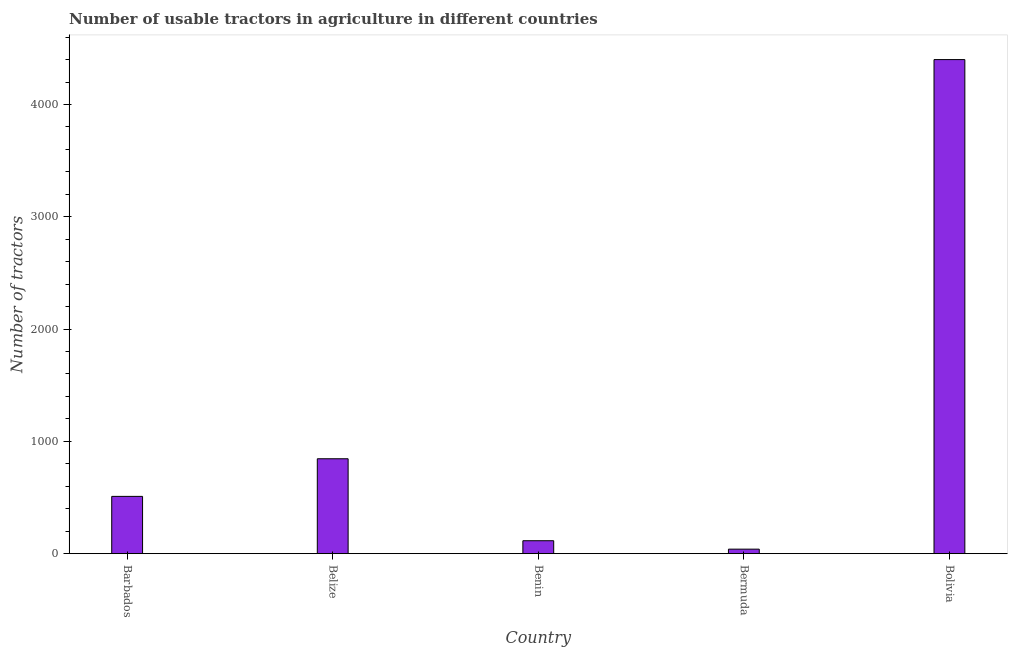Does the graph contain any zero values?
Give a very brief answer. No. What is the title of the graph?
Provide a succinct answer. Number of usable tractors in agriculture in different countries. What is the label or title of the X-axis?
Your answer should be very brief. Country. What is the label or title of the Y-axis?
Make the answer very short. Number of tractors. What is the number of tractors in Belize?
Keep it short and to the point. 845. Across all countries, what is the maximum number of tractors?
Offer a terse response. 4400. In which country was the number of tractors minimum?
Offer a terse response. Bermuda. What is the sum of the number of tractors?
Provide a succinct answer. 5910. What is the difference between the number of tractors in Barbados and Bermuda?
Provide a short and direct response. 470. What is the average number of tractors per country?
Make the answer very short. 1182. What is the median number of tractors?
Keep it short and to the point. 510. What is the ratio of the number of tractors in Bermuda to that in Bolivia?
Provide a short and direct response. 0.01. What is the difference between the highest and the second highest number of tractors?
Your answer should be compact. 3555. Is the sum of the number of tractors in Barbados and Benin greater than the maximum number of tractors across all countries?
Offer a terse response. No. What is the difference between the highest and the lowest number of tractors?
Keep it short and to the point. 4360. How many bars are there?
Your answer should be compact. 5. Are all the bars in the graph horizontal?
Give a very brief answer. No. How many countries are there in the graph?
Keep it short and to the point. 5. What is the difference between two consecutive major ticks on the Y-axis?
Your answer should be compact. 1000. What is the Number of tractors in Barbados?
Your answer should be compact. 510. What is the Number of tractors of Belize?
Your answer should be very brief. 845. What is the Number of tractors in Benin?
Provide a short and direct response. 115. What is the Number of tractors of Bermuda?
Give a very brief answer. 40. What is the Number of tractors in Bolivia?
Make the answer very short. 4400. What is the difference between the Number of tractors in Barbados and Belize?
Offer a very short reply. -335. What is the difference between the Number of tractors in Barbados and Benin?
Give a very brief answer. 395. What is the difference between the Number of tractors in Barbados and Bermuda?
Offer a terse response. 470. What is the difference between the Number of tractors in Barbados and Bolivia?
Your response must be concise. -3890. What is the difference between the Number of tractors in Belize and Benin?
Offer a terse response. 730. What is the difference between the Number of tractors in Belize and Bermuda?
Offer a terse response. 805. What is the difference between the Number of tractors in Belize and Bolivia?
Offer a very short reply. -3555. What is the difference between the Number of tractors in Benin and Bermuda?
Your response must be concise. 75. What is the difference between the Number of tractors in Benin and Bolivia?
Your answer should be compact. -4285. What is the difference between the Number of tractors in Bermuda and Bolivia?
Provide a short and direct response. -4360. What is the ratio of the Number of tractors in Barbados to that in Belize?
Provide a short and direct response. 0.6. What is the ratio of the Number of tractors in Barbados to that in Benin?
Give a very brief answer. 4.43. What is the ratio of the Number of tractors in Barbados to that in Bermuda?
Offer a very short reply. 12.75. What is the ratio of the Number of tractors in Barbados to that in Bolivia?
Your answer should be compact. 0.12. What is the ratio of the Number of tractors in Belize to that in Benin?
Keep it short and to the point. 7.35. What is the ratio of the Number of tractors in Belize to that in Bermuda?
Offer a very short reply. 21.12. What is the ratio of the Number of tractors in Belize to that in Bolivia?
Your answer should be very brief. 0.19. What is the ratio of the Number of tractors in Benin to that in Bermuda?
Ensure brevity in your answer.  2.88. What is the ratio of the Number of tractors in Benin to that in Bolivia?
Your answer should be compact. 0.03. What is the ratio of the Number of tractors in Bermuda to that in Bolivia?
Your answer should be compact. 0.01. 